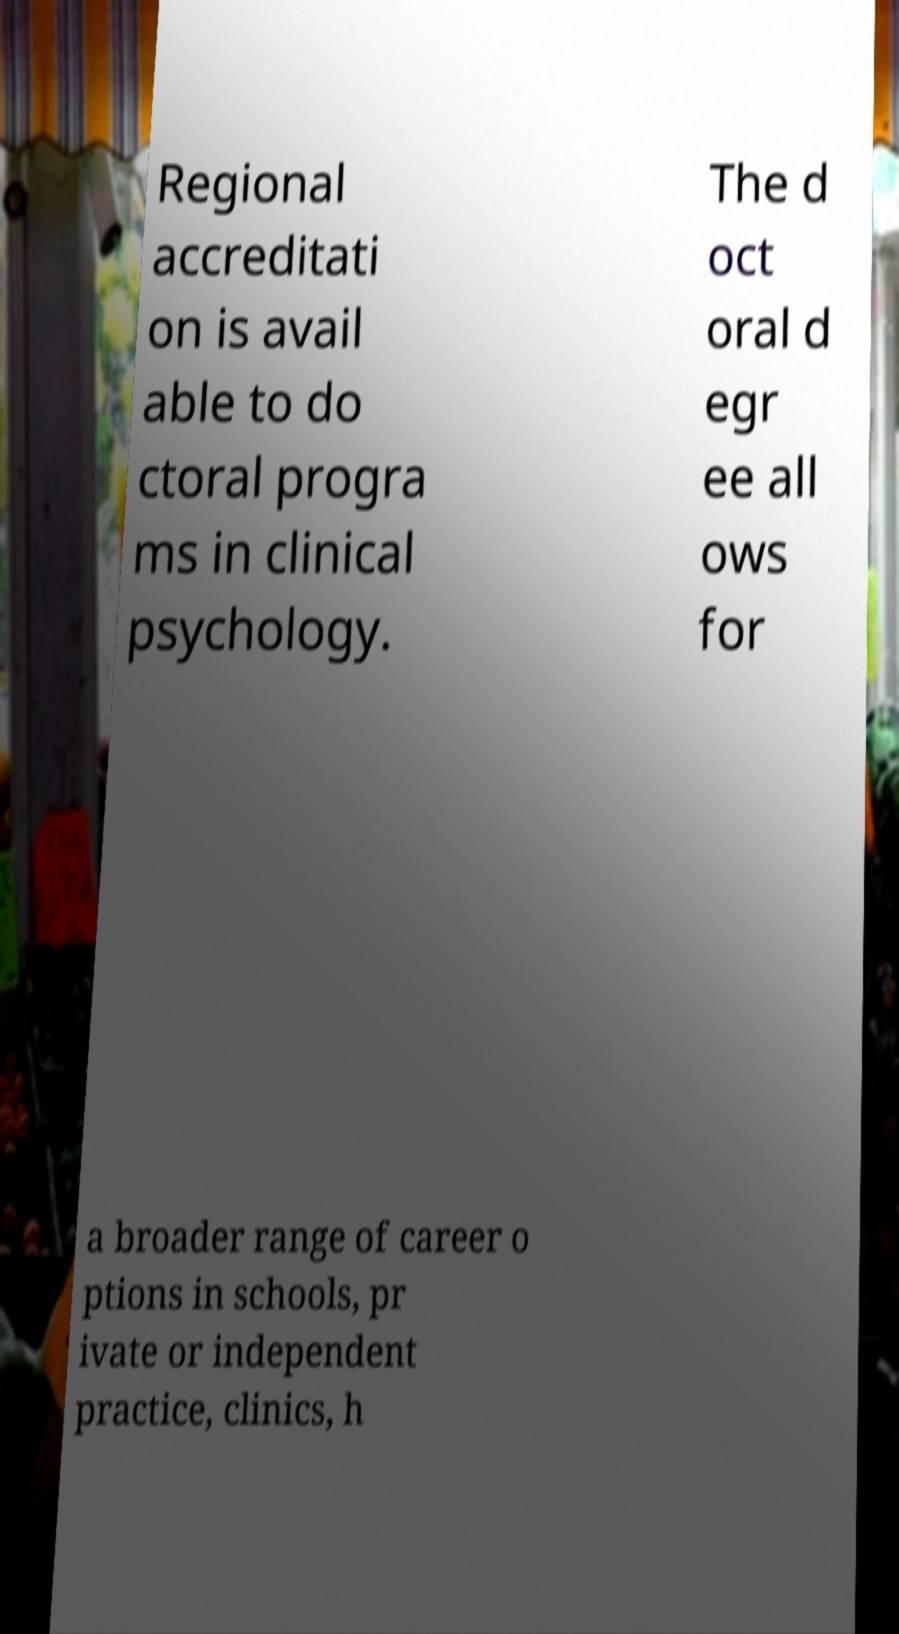I need the written content from this picture converted into text. Can you do that? Regional accreditati on is avail able to do ctoral progra ms in clinical psychology. The d oct oral d egr ee all ows for a broader range of career o ptions in schools, pr ivate or independent practice, clinics, h 